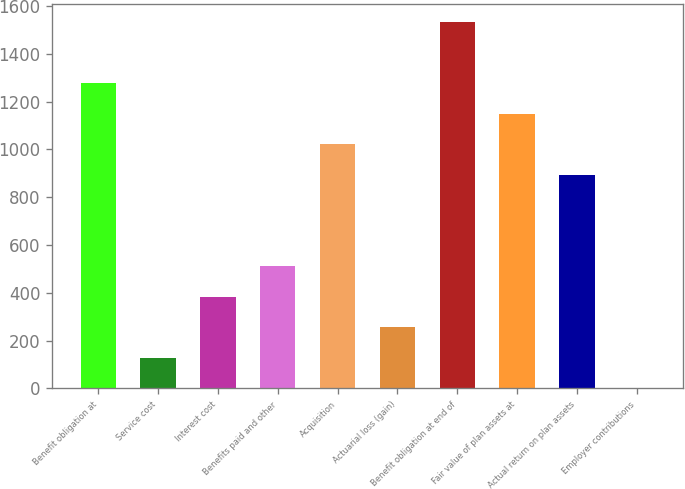Convert chart. <chart><loc_0><loc_0><loc_500><loc_500><bar_chart><fcel>Benefit obligation at<fcel>Service cost<fcel>Interest cost<fcel>Benefits paid and other<fcel>Acquisition<fcel>Actuarial loss (gain)<fcel>Benefit obligation at end of<fcel>Fair value of plan assets at<fcel>Actual return on plan assets<fcel>Employer contributions<nl><fcel>1276.8<fcel>128.31<fcel>383.53<fcel>511.14<fcel>1021.58<fcel>255.92<fcel>1532.02<fcel>1149.19<fcel>893.97<fcel>0.7<nl></chart> 